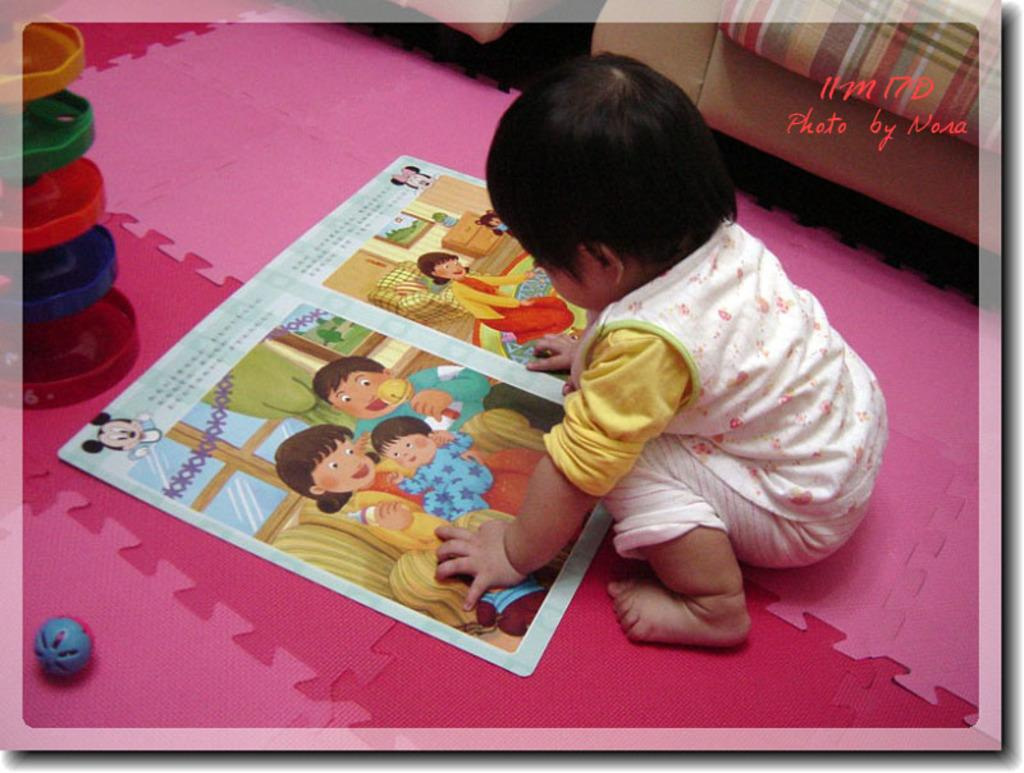What is the main subject of the image? There is a child in the image. What objects are present with the child? There is a book, a ball, and a toy in the image. Where are these objects located? All these objects are on the floor. What can be seen in the background of the image? There are chairs in the background of the image. What type of peace symbol can be seen in the image? There is no peace symbol present in the image. Is there a hose visible in the image? No, there is no hose visible in the image. 